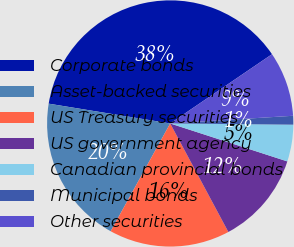Convert chart. <chart><loc_0><loc_0><loc_500><loc_500><pie_chart><fcel>Corporate bonds<fcel>Asset-backed securities<fcel>US Treasury securities<fcel>US government agency<fcel>Canadian provincial bonds<fcel>Municipal bonds<fcel>Other securities<nl><fcel>37.92%<fcel>19.54%<fcel>15.86%<fcel>12.18%<fcel>4.83%<fcel>1.15%<fcel>8.51%<nl></chart> 